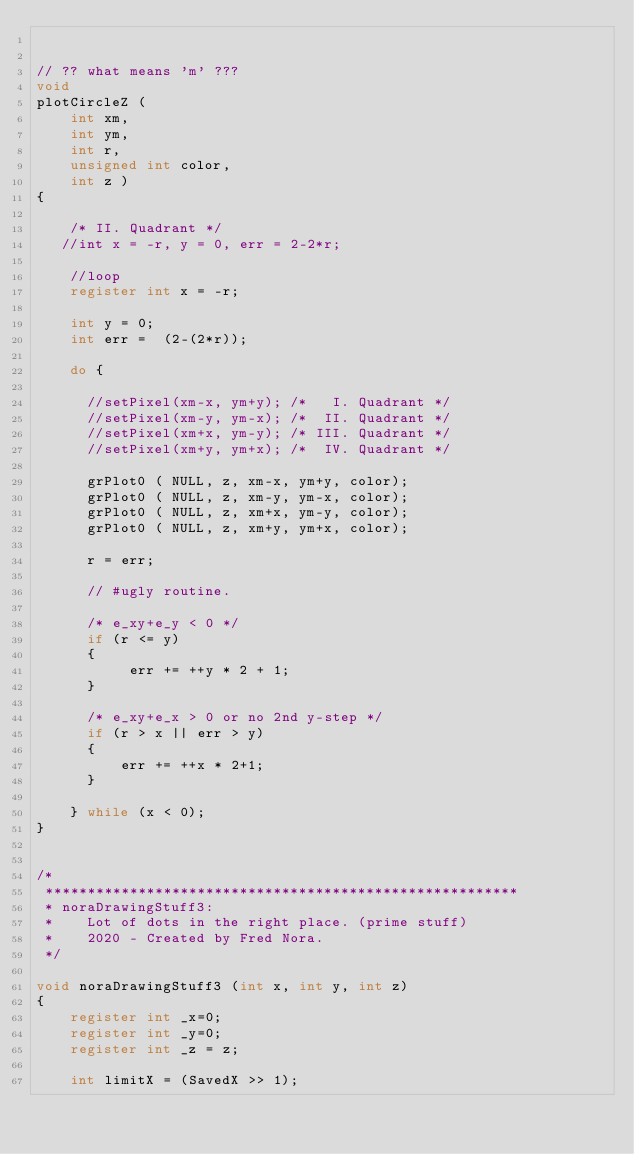<code> <loc_0><loc_0><loc_500><loc_500><_C_>

// ?? what means 'm' ???
void 
plotCircleZ ( 
    int xm, 
    int ym, 
    int r, 
    unsigned int color, 
    int z )
{

    /* II. Quadrant */ 
   //int x = -r, y = 0, err = 2-2*r; 
   
    //loop
    register int x = -r;
   
    int y = 0;
    int err =  (2-(2*r));

    do {
      
      //setPixel(xm-x, ym+y); /*   I. Quadrant */
      //setPixel(xm-y, ym-x); /*  II. Quadrant */
      //setPixel(xm+x, ym-y); /* III. Quadrant */
      //setPixel(xm+y, ym+x); /*  IV. Quadrant */
      
      grPlot0 ( NULL, z, xm-x, ym+y, color);
      grPlot0 ( NULL, z, xm-y, ym-x, color);
      grPlot0 ( NULL, z, xm+x, ym-y, color);
      grPlot0 ( NULL, z, xm+y, ym+x, color);

      r = err;
      
      // #ugly routine.
      
      /* e_xy+e_y < 0 */
      if (r <= y) 
      { 
           err += ++y * 2 + 1; 
      }           
      
      /* e_xy+e_x > 0 or no 2nd y-step */
      if (r > x || err > y) 
      { 
          err += ++x * 2+1; 
      }
      
    } while (x < 0);
}


/*
 ********************************************************
 * noraDrawingStuff3: 
 *    Lot of dots in the right place. (prime stuff)
 *    2020 - Created by Fred Nora. 
 */

void noraDrawingStuff3 (int x, int y, int z)
{
    register int _x=0;
    register int _y=0;
    register int _z = z;

    int limitX = (SavedX >> 1);</code> 